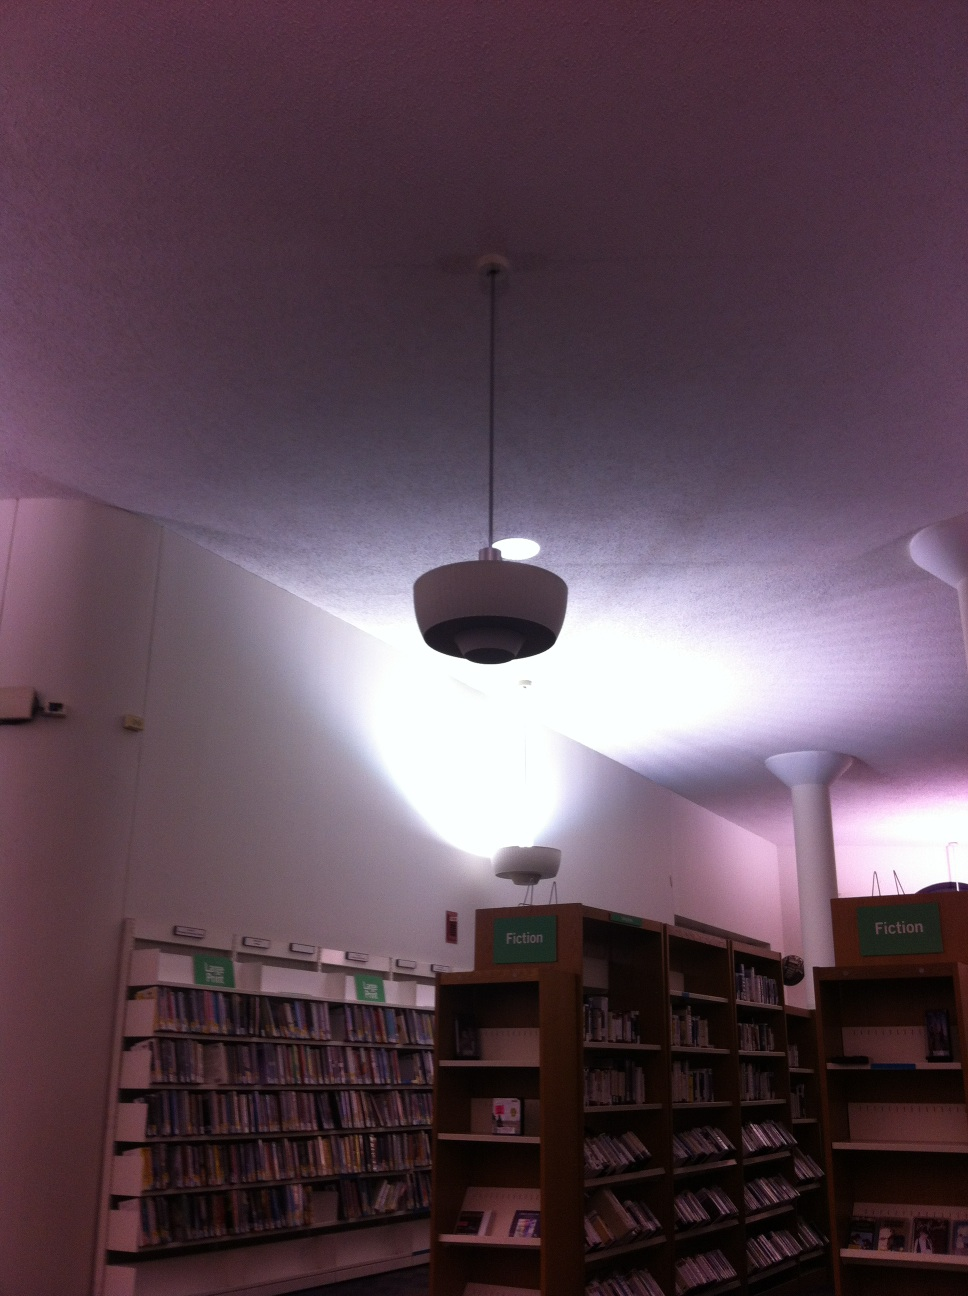What kinds of books can I find here? In this section of the library, you can find numerous fiction books. These include genres ranging from romance, mystery, science fiction, to fantasy and historical fiction. The shelves are well-organized to help you find the type of book that suits your interest. Can you recommend a popular fiction book for me? Sure! 'To Kill a Mockingbird' by Harper Lee is a highly recommended classic that you might enjoy. It offers a profound narrative that explores themes of justice and moral growth. 